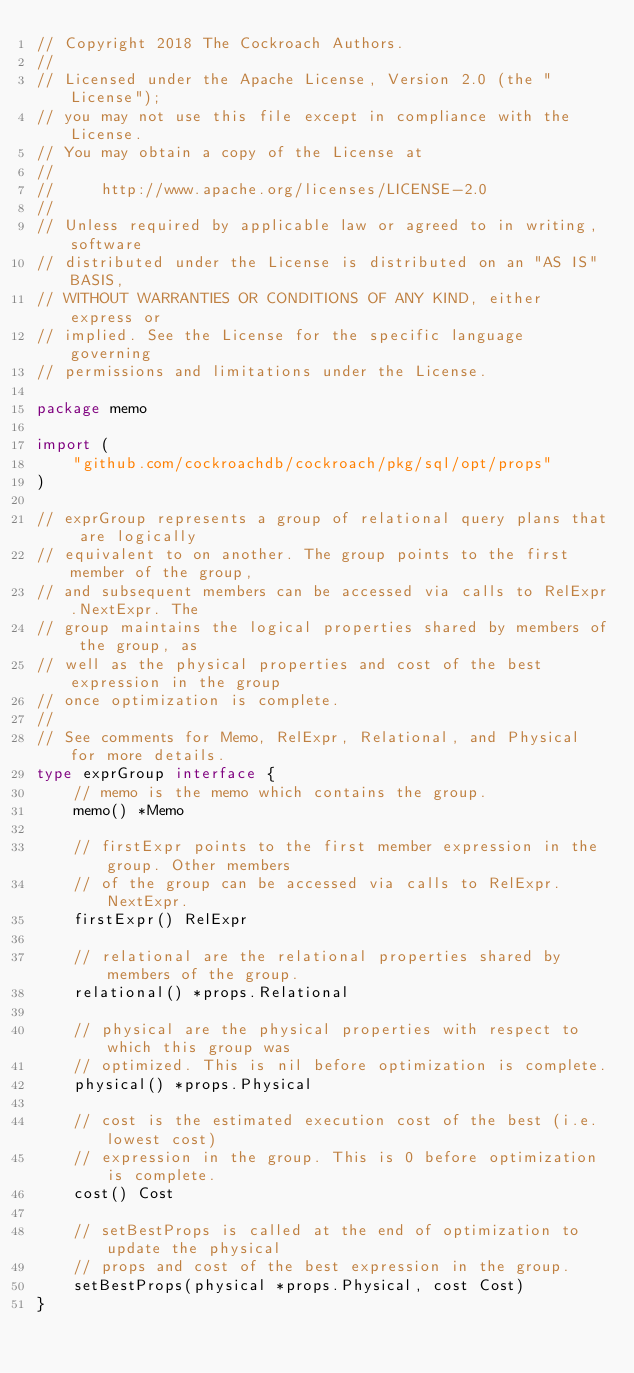<code> <loc_0><loc_0><loc_500><loc_500><_Go_>// Copyright 2018 The Cockroach Authors.
//
// Licensed under the Apache License, Version 2.0 (the "License");
// you may not use this file except in compliance with the License.
// You may obtain a copy of the License at
//
//     http://www.apache.org/licenses/LICENSE-2.0
//
// Unless required by applicable law or agreed to in writing, software
// distributed under the License is distributed on an "AS IS" BASIS,
// WITHOUT WARRANTIES OR CONDITIONS OF ANY KIND, either express or
// implied. See the License for the specific language governing
// permissions and limitations under the License.

package memo

import (
	"github.com/cockroachdb/cockroach/pkg/sql/opt/props"
)

// exprGroup represents a group of relational query plans that are logically
// equivalent to on another. The group points to the first member of the group,
// and subsequent members can be accessed via calls to RelExpr.NextExpr. The
// group maintains the logical properties shared by members of the group, as
// well as the physical properties and cost of the best expression in the group
// once optimization is complete.
//
// See comments for Memo, RelExpr, Relational, and Physical for more details.
type exprGroup interface {
	// memo is the memo which contains the group.
	memo() *Memo

	// firstExpr points to the first member expression in the group. Other members
	// of the group can be accessed via calls to RelExpr.NextExpr.
	firstExpr() RelExpr

	// relational are the relational properties shared by members of the group.
	relational() *props.Relational

	// physical are the physical properties with respect to which this group was
	// optimized. This is nil before optimization is complete.
	physical() *props.Physical

	// cost is the estimated execution cost of the best (i.e. lowest cost)
	// expression in the group. This is 0 before optimization is complete.
	cost() Cost

	// setBestProps is called at the end of optimization to update the physical
	// props and cost of the best expression in the group.
	setBestProps(physical *props.Physical, cost Cost)
}
</code> 